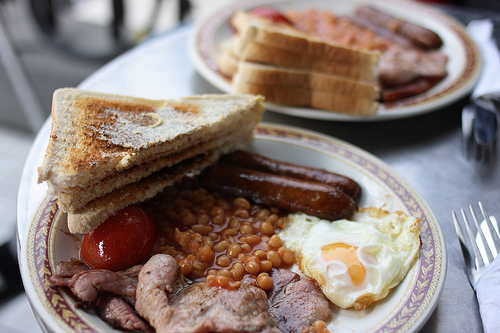<image>
Is there a toast on the plate? Yes. Looking at the image, I can see the toast is positioned on top of the plate, with the plate providing support. 